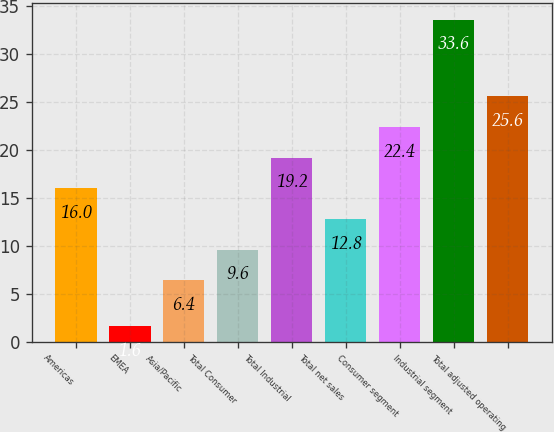Convert chart. <chart><loc_0><loc_0><loc_500><loc_500><bar_chart><fcel>Americas<fcel>EMEA<fcel>Asia/Pacific<fcel>Total Consumer<fcel>Total Industrial<fcel>Total net sales<fcel>Consumer segment<fcel>Industrial segment<fcel>Total adjusted operating<nl><fcel>16<fcel>1.6<fcel>6.4<fcel>9.6<fcel>19.2<fcel>12.8<fcel>22.4<fcel>33.6<fcel>25.6<nl></chart> 